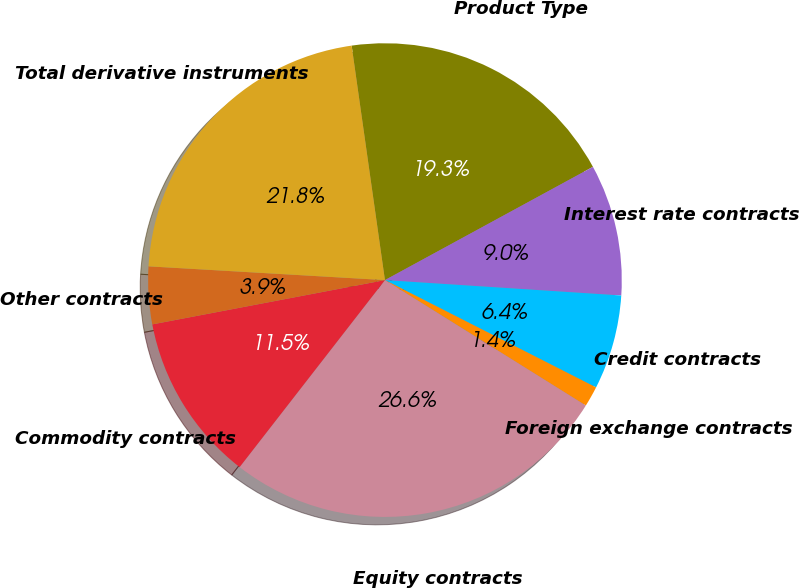Convert chart to OTSL. <chart><loc_0><loc_0><loc_500><loc_500><pie_chart><fcel>Product Type<fcel>Interest rate contracts<fcel>Credit contracts<fcel>Foreign exchange contracts<fcel>Equity contracts<fcel>Commodity contracts<fcel>Other contracts<fcel>Total derivative instruments<nl><fcel>19.31%<fcel>8.97%<fcel>6.45%<fcel>1.4%<fcel>26.63%<fcel>11.49%<fcel>3.92%<fcel>21.83%<nl></chart> 